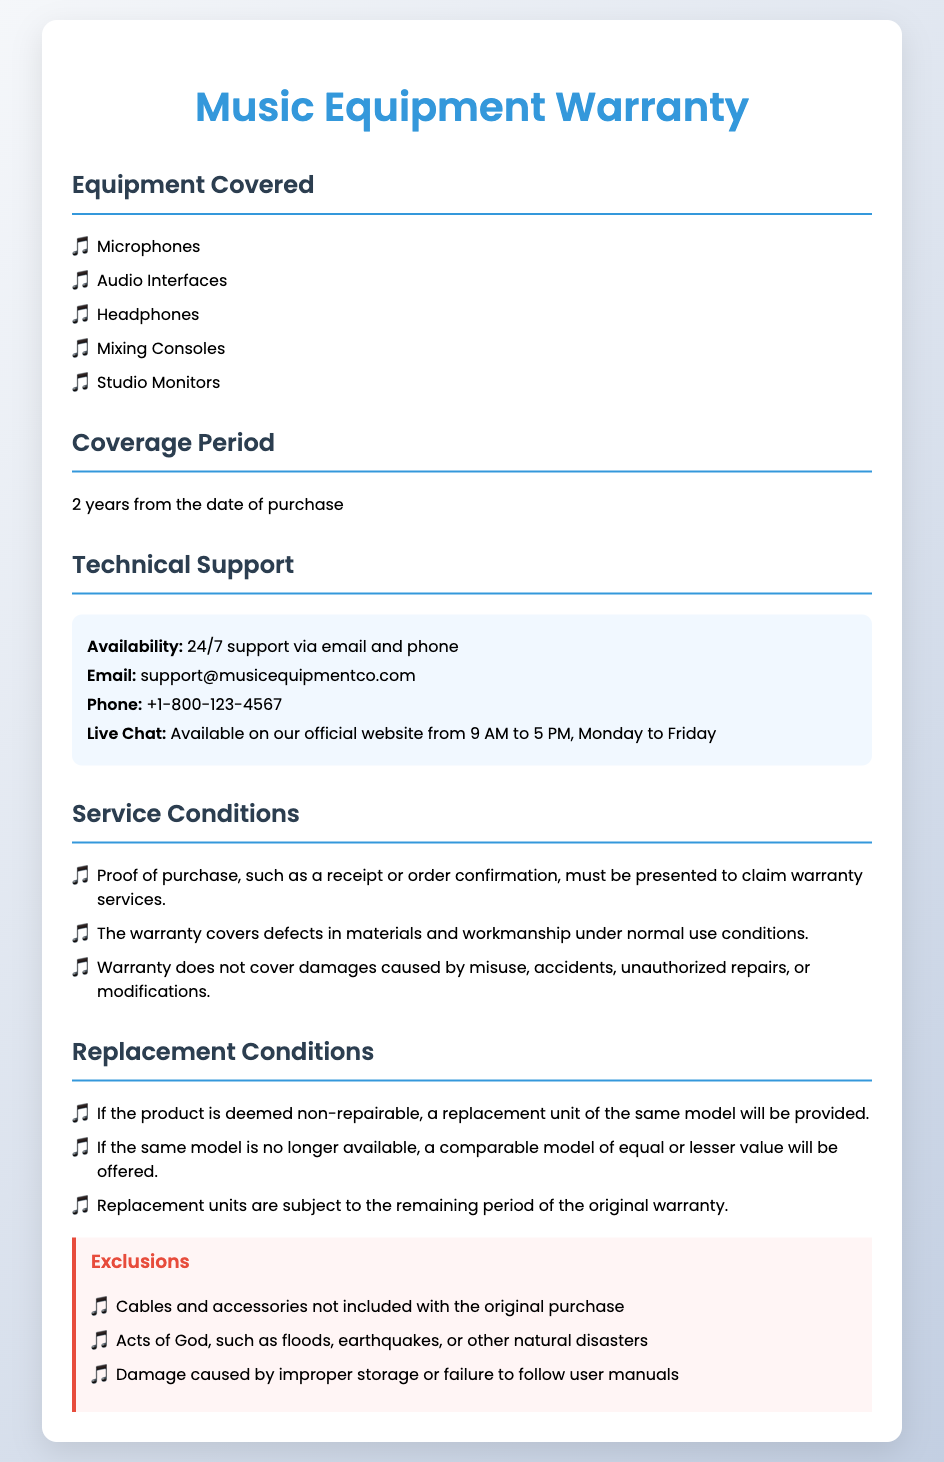What is the coverage period? The coverage period is specified in the document as the time frame for warranty protection, which is 2 years from the date of purchase.
Answer: 2 years What types of equipment are covered? The types of equipment that are covered are listed in a section, including microphones and others.
Answer: Microphones, Audio Interfaces, Headphones, Mixing Consoles, Studio Monitors What type of support is available? The document details the availability of technical support, which includes 24/7 support via multiple channels.
Answer: 24/7 support What must be presented to claim warranty services? The document states that proof of purchase is necessary, which can include a receipt or order confirmation.
Answer: Proof of purchase What happens if the product is non-repairable? Regarding non-repairable products, the document explains that a specific action will be taken, such as providing a replacement unit of the same model.
Answer: Replacement unit of the same model What is excluded from the warranty? The document has a list of exclusions that are not covered by the warranty, including cables and accessories.
Answer: Cables and accessories Where should support requests be sent? The document specifies a contact method for support requests, particularly mentioning email for support inquiries.
Answer: support@musicequipmentco.com What is the contact phone number for support? The document provides a contact phone number for technical support, which is stated clearly.
Answer: +1-800-123-4567 